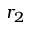<formula> <loc_0><loc_0><loc_500><loc_500>r _ { 2 }</formula> 